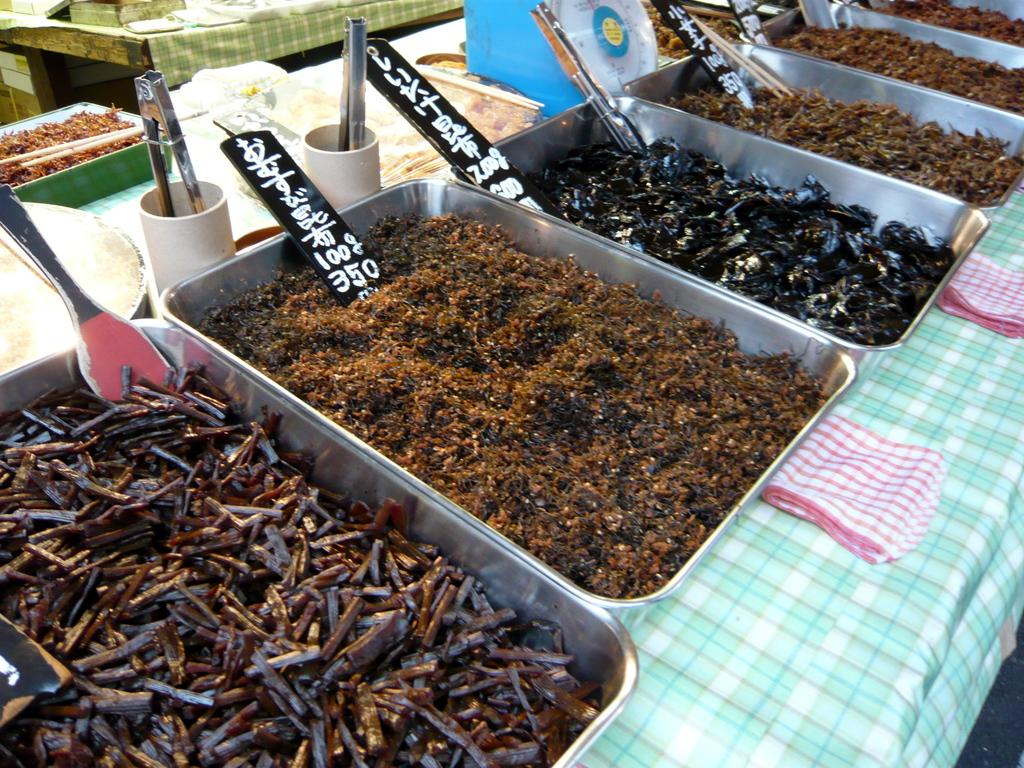What can be found inside the containers in the image? There are objects in the containers in the image. Are there any goldfish swimming in the containers in the image? There is no mention of goldfish or any aquatic creatures in the image, so we cannot confirm their presence. 